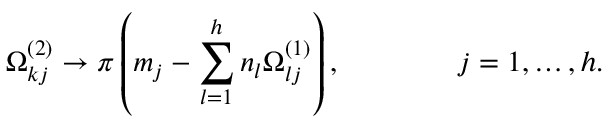<formula> <loc_0><loc_0><loc_500><loc_500>\Omega _ { k j } ^ { ( 2 ) } \to \pi \left ( m _ { j } - \sum _ { l = 1 } ^ { h } n _ { l } \Omega _ { l j } ^ { ( 1 ) } \right ) , \quad j = 1 , \dots , h .</formula> 